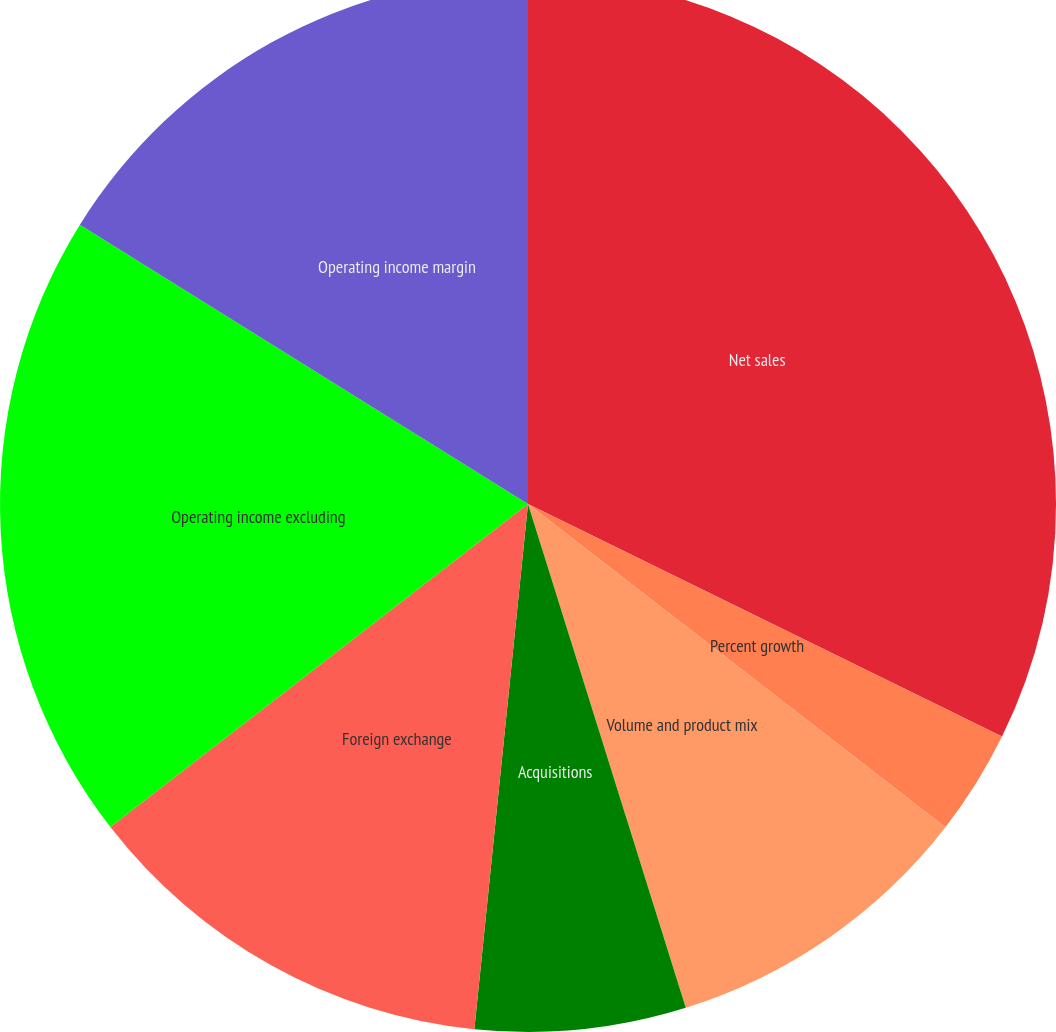Convert chart to OTSL. <chart><loc_0><loc_0><loc_500><loc_500><pie_chart><fcel>Net sales<fcel>Percent growth<fcel>Volume and product mix<fcel>Pricing actions<fcel>Acquisitions<fcel>Foreign exchange<fcel>Operating income excluding<fcel>Operating income margin<nl><fcel>32.26%<fcel>3.23%<fcel>9.68%<fcel>0.0%<fcel>6.45%<fcel>12.9%<fcel>19.35%<fcel>16.13%<nl></chart> 